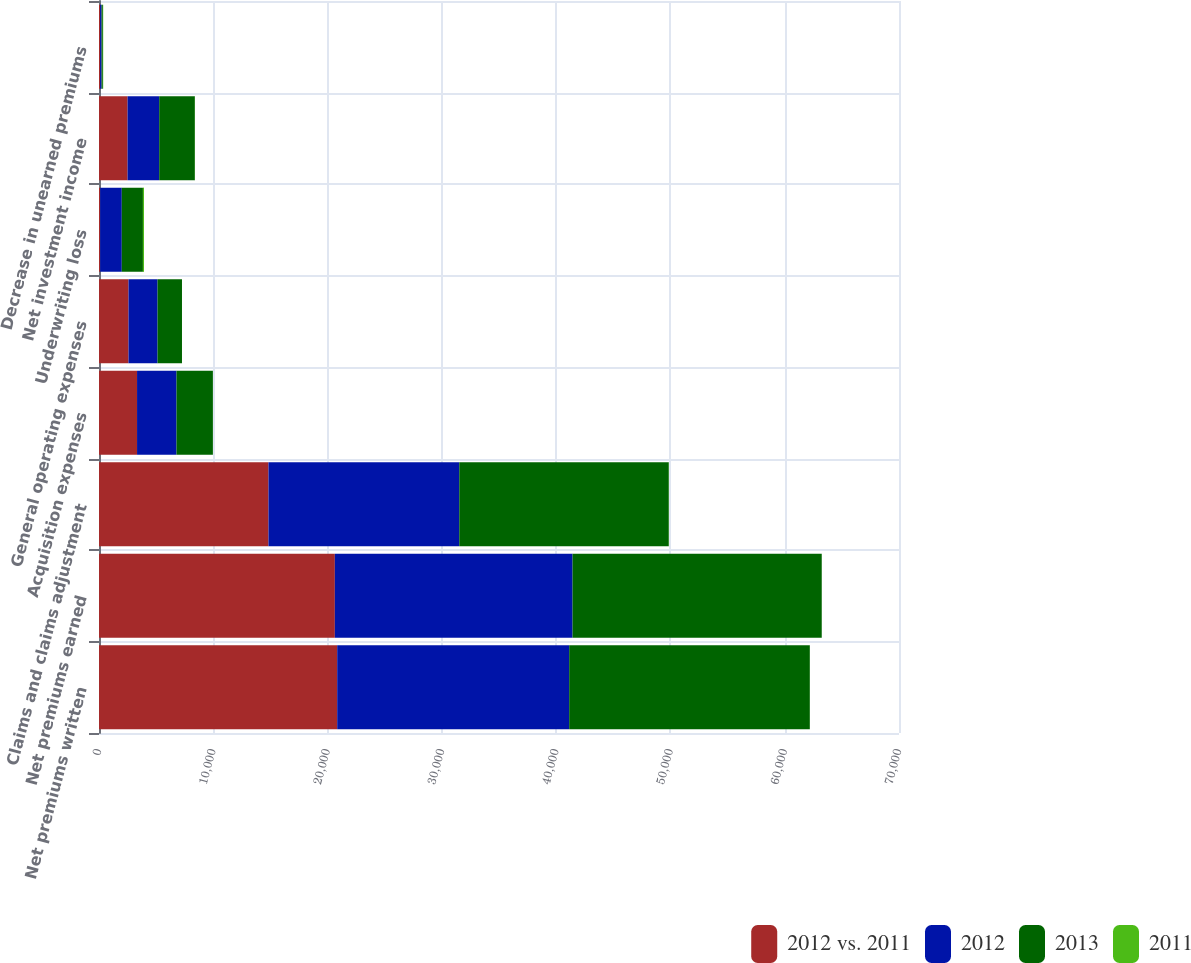Convert chart to OTSL. <chart><loc_0><loc_0><loc_500><loc_500><stacked_bar_chart><ecel><fcel>Net premiums written<fcel>Net premiums earned<fcel>Claims and claims adjustment<fcel>Acquisition expenses<fcel>General operating expenses<fcel>Underwriting loss<fcel>Net investment income<fcel>Decrease in unearned premiums<nl><fcel>2012 vs. 2011<fcel>20842<fcel>20637<fcel>14828<fcel>3329<fcel>2582<fcel>102<fcel>2500<fcel>93<nl><fcel>2012<fcel>20300<fcel>20800<fcel>16696<fcel>3453<fcel>2543<fcel>1892<fcel>2769<fcel>135<nl><fcel>2013<fcel>21055<fcel>21803<fcel>18332<fcel>3184<fcel>2136<fcel>1849<fcel>3118<fcel>108<nl><fcel>2011<fcel>3<fcel>1<fcel>11<fcel>4<fcel>2<fcel>95<fcel>10<fcel>31<nl></chart> 